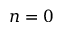Convert formula to latex. <formula><loc_0><loc_0><loc_500><loc_500>n = 0</formula> 